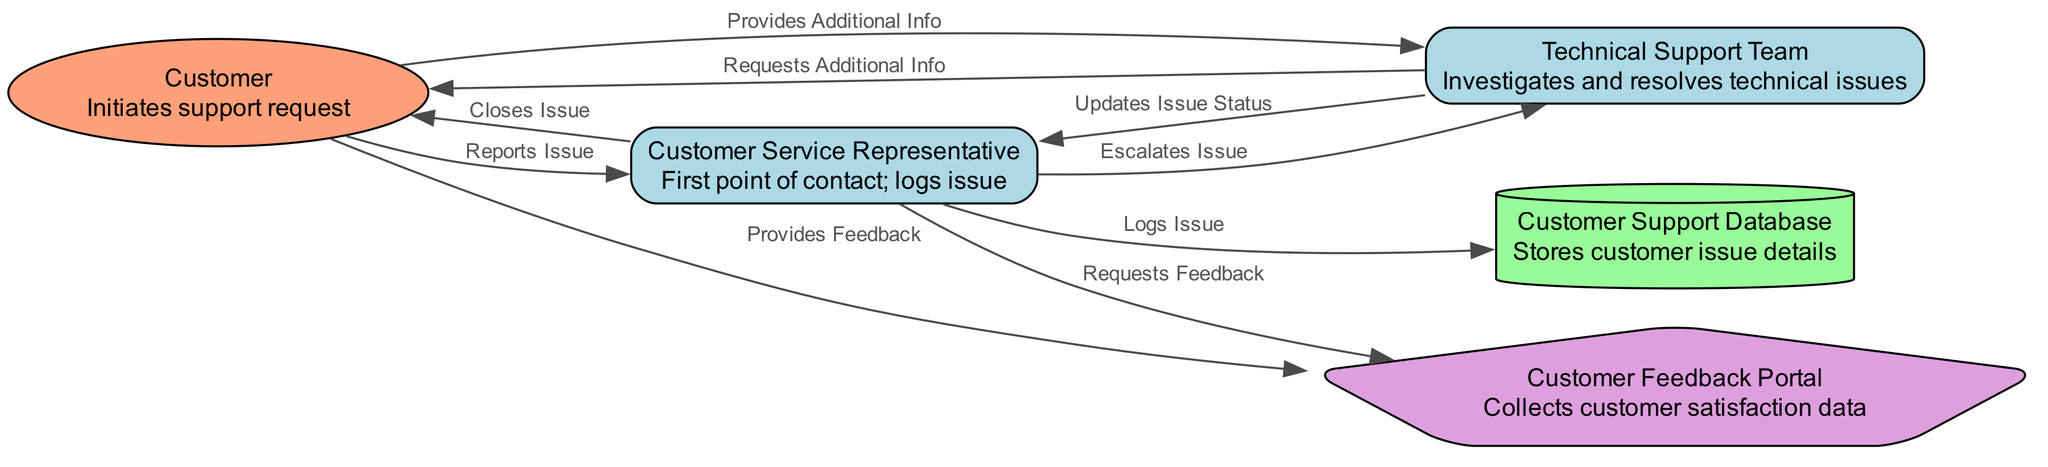What is the first point of contact for customer support requests? The diagram indicates that the "Customer Service Representative" is the first point of contact after a customer initiates a support request.
Answer: Customer Service Representative How many edges are in the diagram? By counting the connections (edges) between nodes, we find there are 9 edges directly indicated in the diagram.
Answer: 9 Who logs the issue reported by the customer? The diagram illustrates that the "Customer Service Representative" is responsible for logging the issue as the first step in the process.
Answer: Customer Service Representative What does the Technical Support Team do in the resolution process? The diagram shows that the "Technical Support Team" investigates and resolves technical issues before updating the issue status.
Answer: Investigates and resolves technical issues What shape represents the Customer Feedback Portal in the diagram? The diagram specifies that the "Customer Feedback Portal" is depicted as a pentagon, indicating its unique function in collecting customer satisfaction data.
Answer: Pentagon What follows after the Technical Support Team requests additional information from the Customer? According to the diagram flow, after the "Technical Support Team" requests additional information, the "Customer" provides additional information in response.
Answer: Provides Additional Info How many nodes are involved in the resolution chain? By identifying each unique entity in the diagram, it is established that there are 6 distinct nodes participating in the customer support and service resolution process.
Answer: 6 What action does the Customer Service Representative take to close the issue? The diagram states that the "Customer Service Representative" takes the final action of "Closes Issue," marking the endpoint of the service resolution chain.
Answer: Closes Issue What is the role of the Customer Support Database in the process? The diagram clarifies that the "Customer Support Database" serves to store customer issue details, playing a critical role in tracking support requests.
Answer: Stores customer issue details 